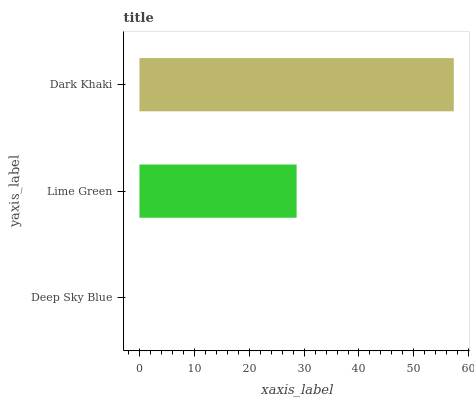Is Deep Sky Blue the minimum?
Answer yes or no. Yes. Is Dark Khaki the maximum?
Answer yes or no. Yes. Is Lime Green the minimum?
Answer yes or no. No. Is Lime Green the maximum?
Answer yes or no. No. Is Lime Green greater than Deep Sky Blue?
Answer yes or no. Yes. Is Deep Sky Blue less than Lime Green?
Answer yes or no. Yes. Is Deep Sky Blue greater than Lime Green?
Answer yes or no. No. Is Lime Green less than Deep Sky Blue?
Answer yes or no. No. Is Lime Green the high median?
Answer yes or no. Yes. Is Lime Green the low median?
Answer yes or no. Yes. Is Deep Sky Blue the high median?
Answer yes or no. No. Is Deep Sky Blue the low median?
Answer yes or no. No. 